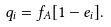Convert formula to latex. <formula><loc_0><loc_0><loc_500><loc_500>q _ { i } = f _ { A } [ 1 - e _ { i } ] .</formula> 